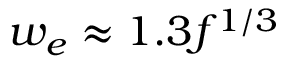Convert formula to latex. <formula><loc_0><loc_0><loc_500><loc_500>w _ { e } \approx 1 . 3 f ^ { 1 / 3 }</formula> 